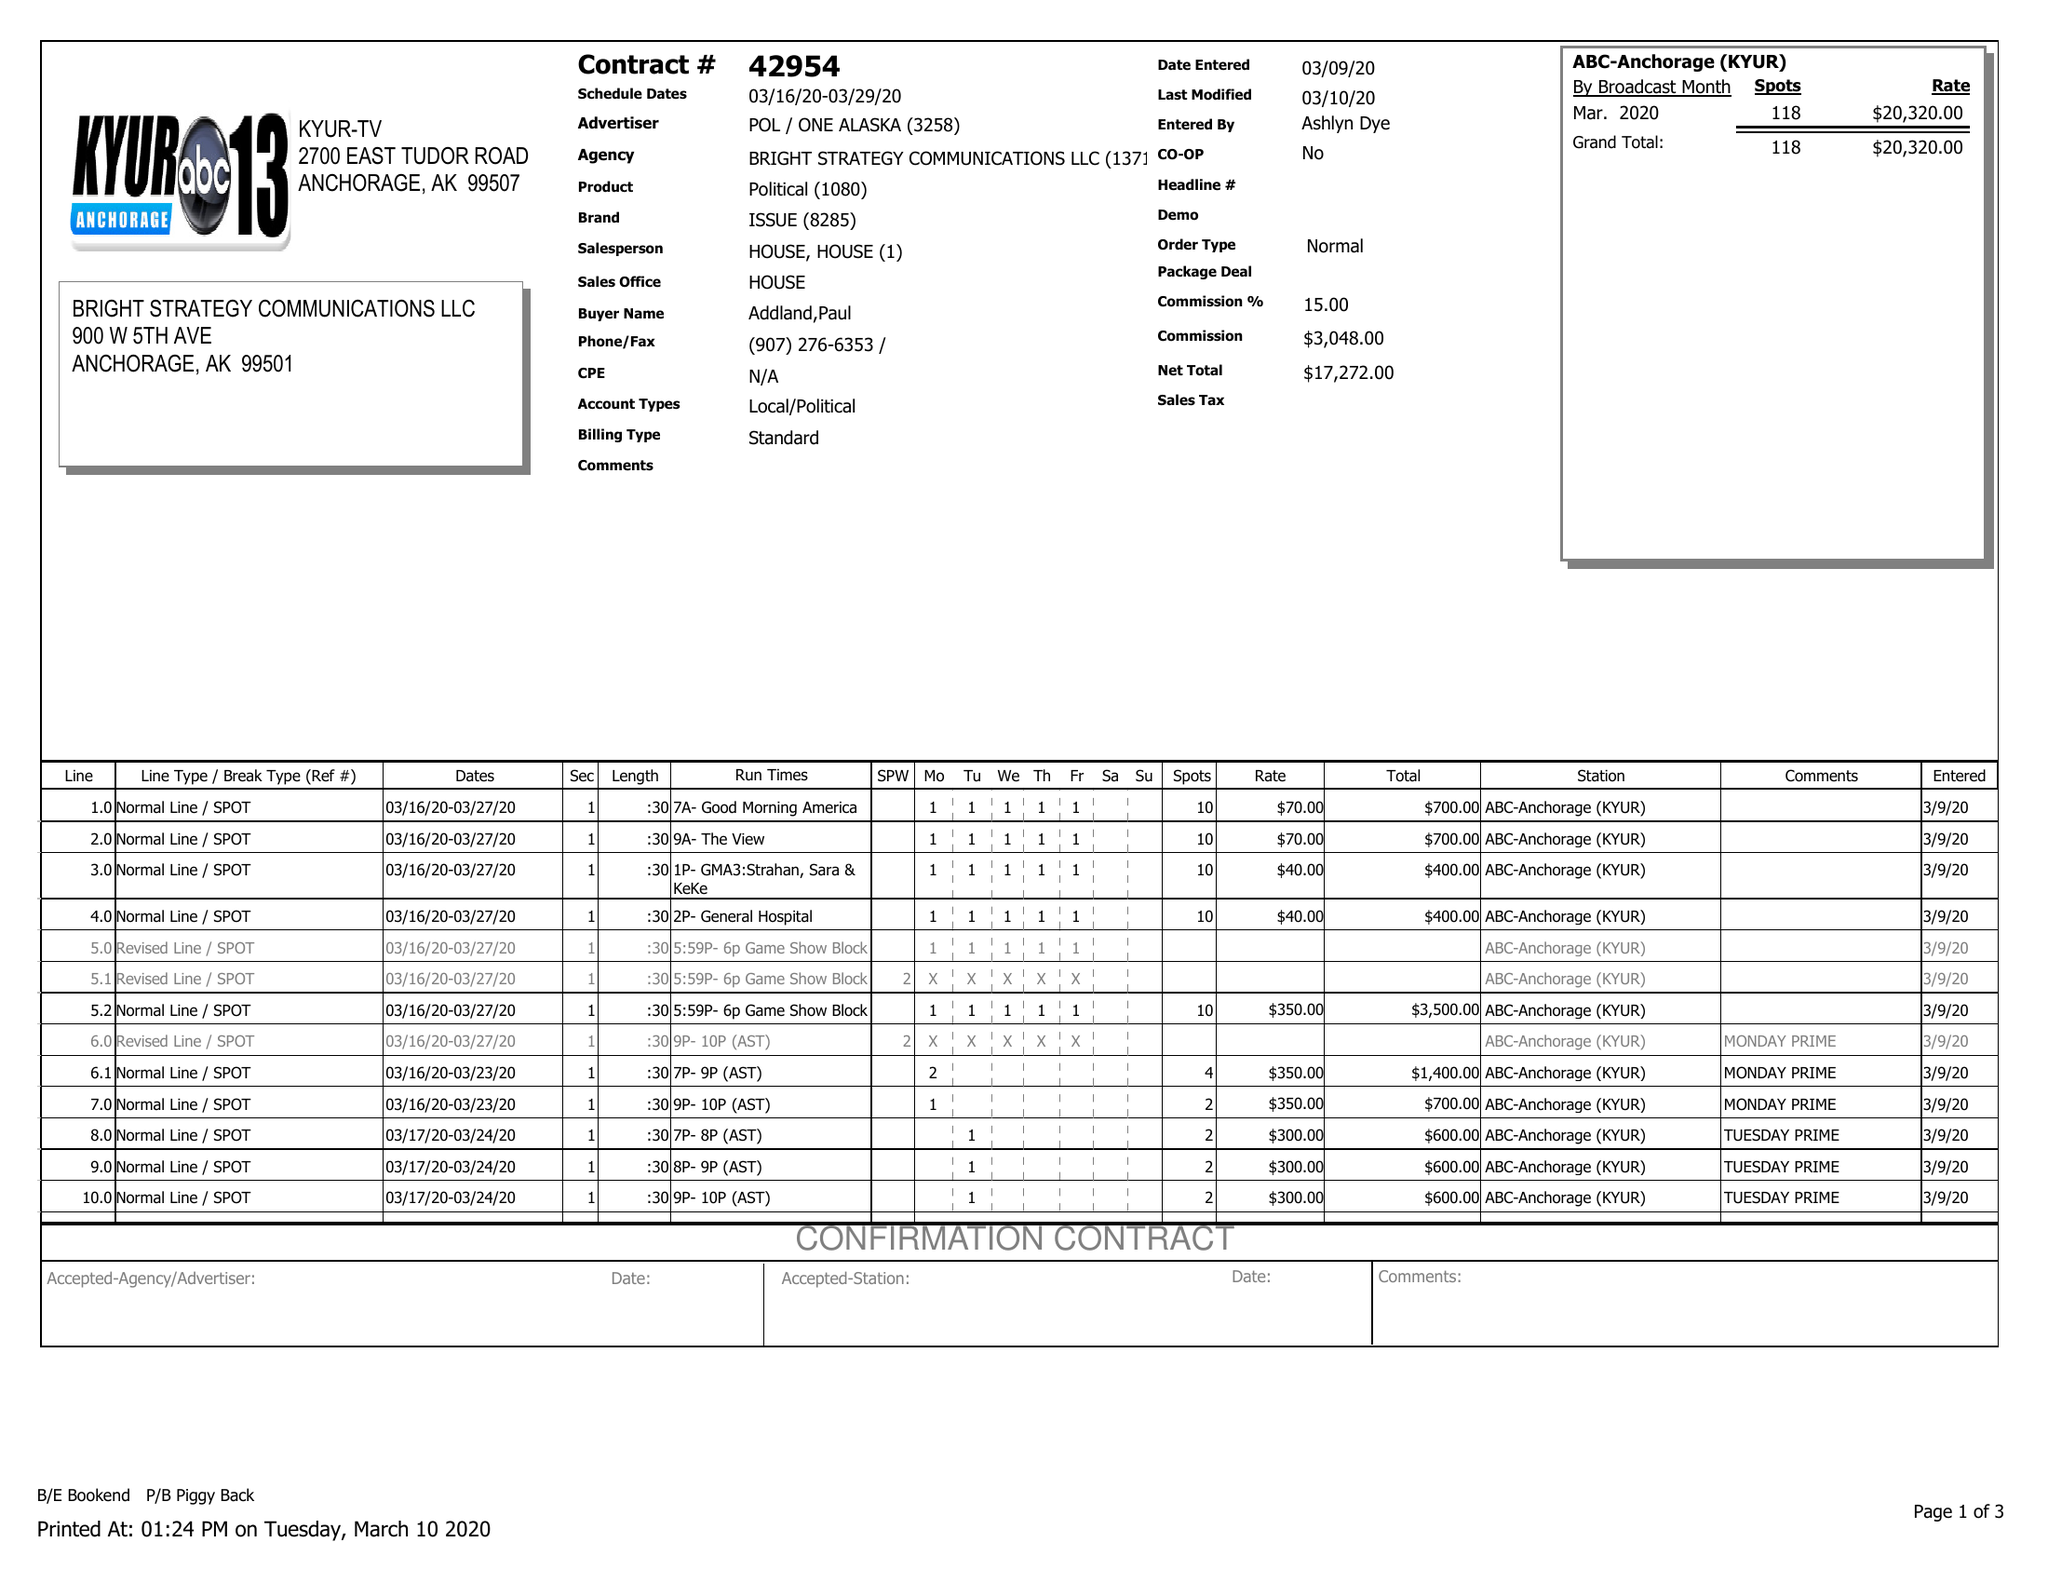What is the value for the flight_to?
Answer the question using a single word or phrase. 03/29/20 